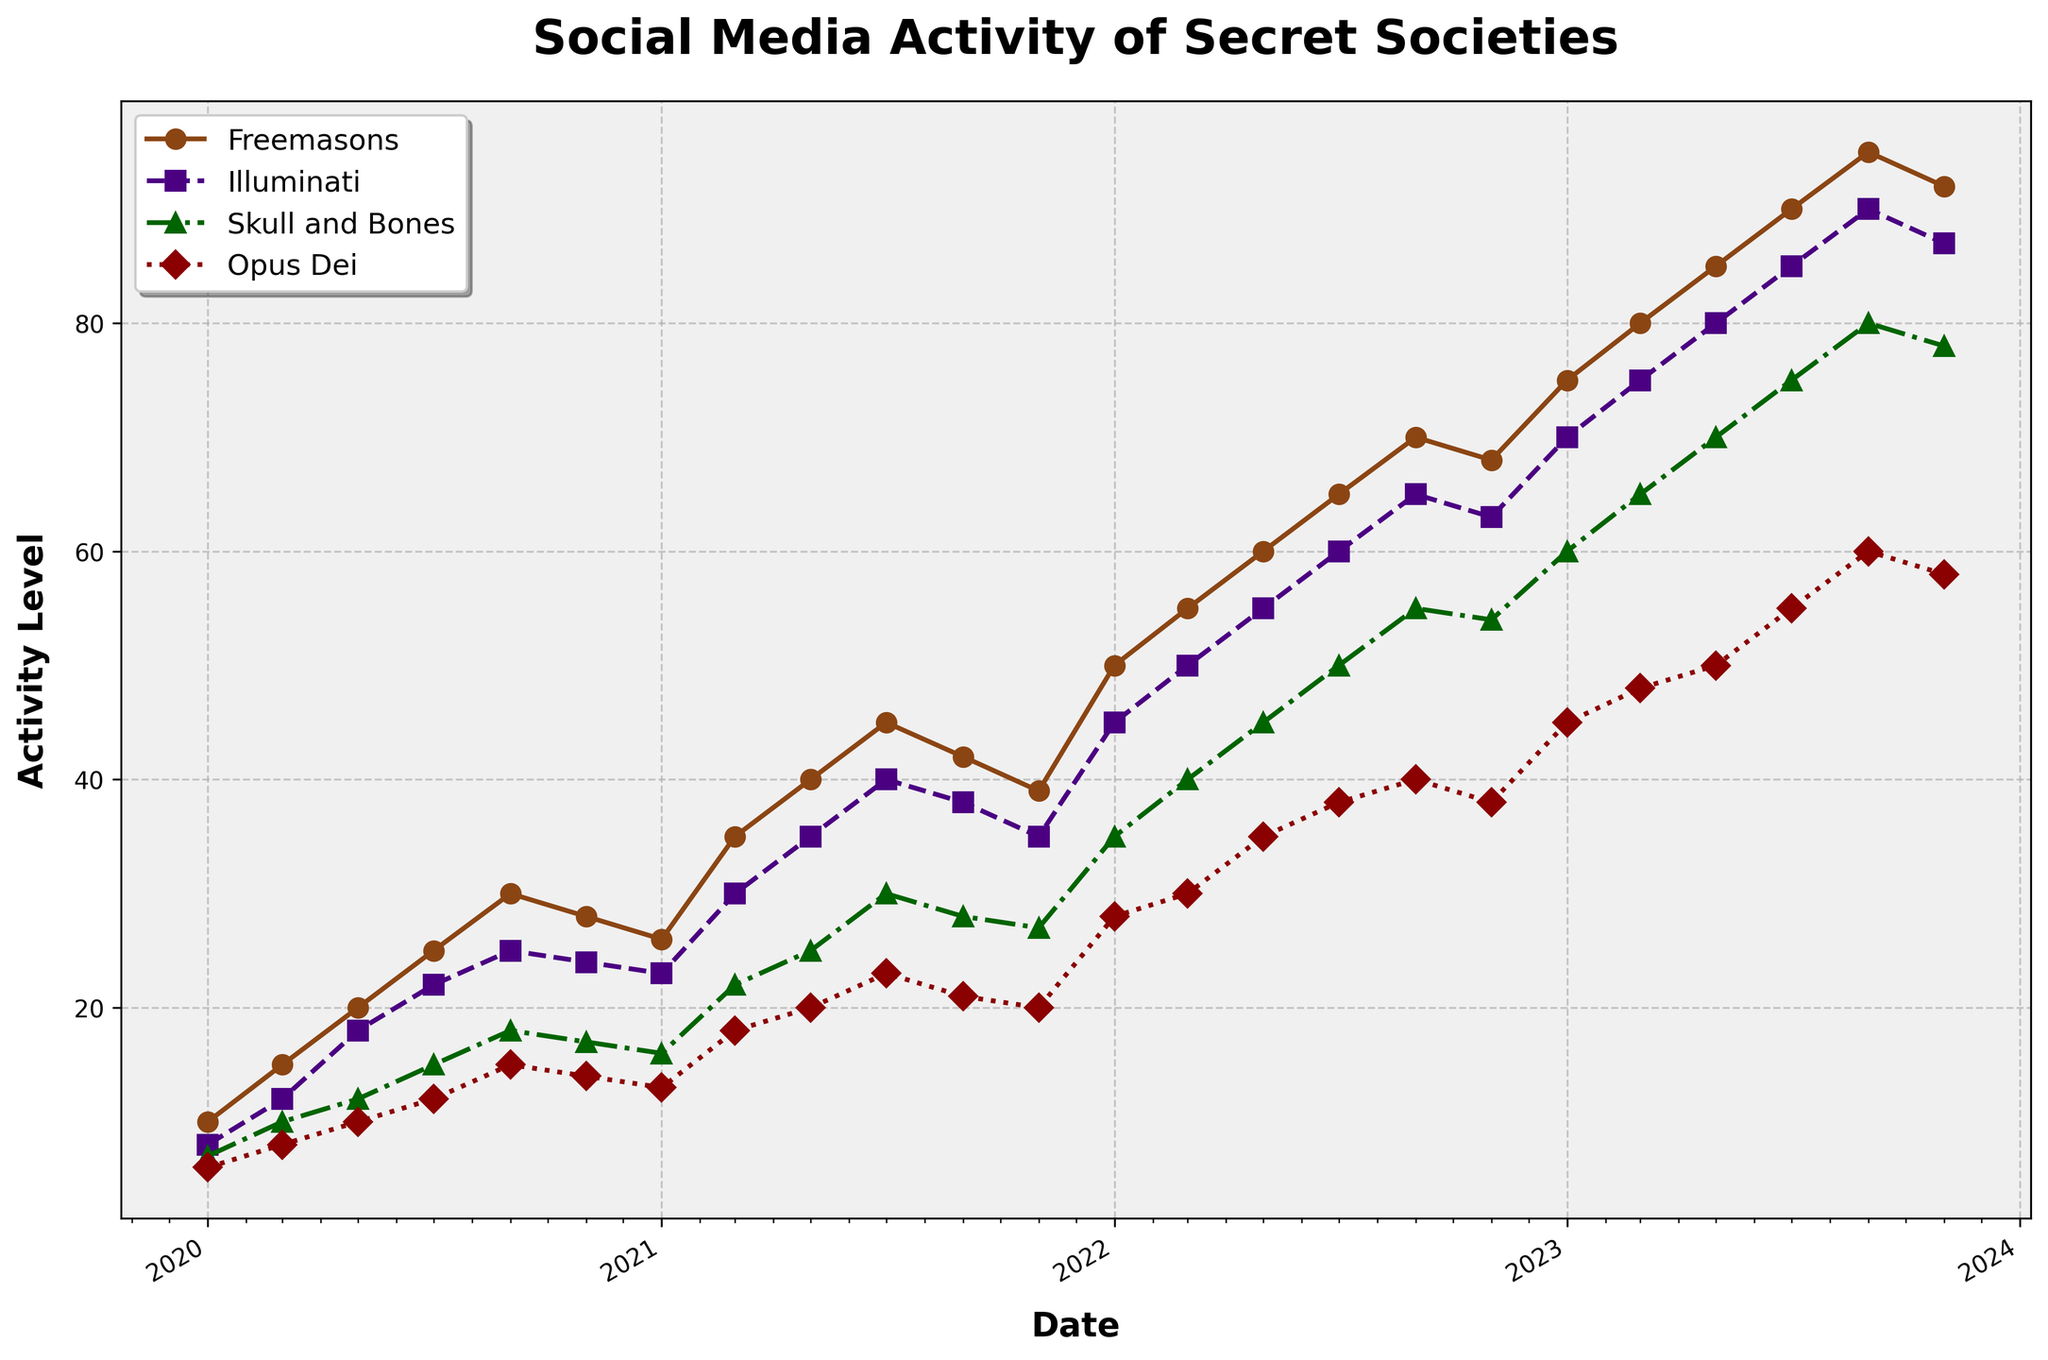How does the activity of Freemasons change over time? The activity level of Freemasons consistently increases over time, with occasional slight dips, peaking in the latest data points around 2023-09-01 and 2023-11-01.
Answer: It increases with slight dips Which secret society shows the highest activity level in 2021-07-01? On 2021-07-01, the Freemasons show the highest activity level compared to other secret societies in the plot.
Answer: Freemasons What is the average activity level of Illuminati from the data provided? Sum all the activity levels of Illuminati from the figure, and then divide by the total number of data points (23). Sum = 8 + 12 + 18 + 22 + 25 + 24 + 23 + 30 + 35 + 40 + 38 + 35 + 45 + 50 + 55 + 60 + 65 + 63 + 70 + 75 + 80 + 85 + 90 = 1058. Average = 1058 / 23
Answer: 46 What trends do you observe in the activity levels of Opus Dei during the last quarter of 2023? The activity levels of Opus Dei show a decreasing trend in the last quarter of 2023, with a peak in 2023-07-01 and subsequent drops in the following months.
Answer: Decreasing Do the Skull and Bones ever surpass the activity level of the Illuminati? By comparing the plots of Skull and Bones and Illuminati, the data shows that at no point does the activity level of Skull and Bones exceed that of the Illuminati.
Answer: No Which secret society has the most stable activity trend over time? Opus Dei shows the most stable trend over time, with fewer fluctuations in its activity levels in comparison to other secret societies, indicated by its relatively smooth and consistent curve in the plot.
Answer: Opus Dei In which date period does the Freemasons' activity level decrease, and what are the values before and after the drop? The Freemasons' activity level decreases between 2020-09-01 and 2021-01-01. The values are 30 before the drop and 26 after the drop.
Answer: Between 2020-09-01 and 2021-01-01, values are 30 and 26 